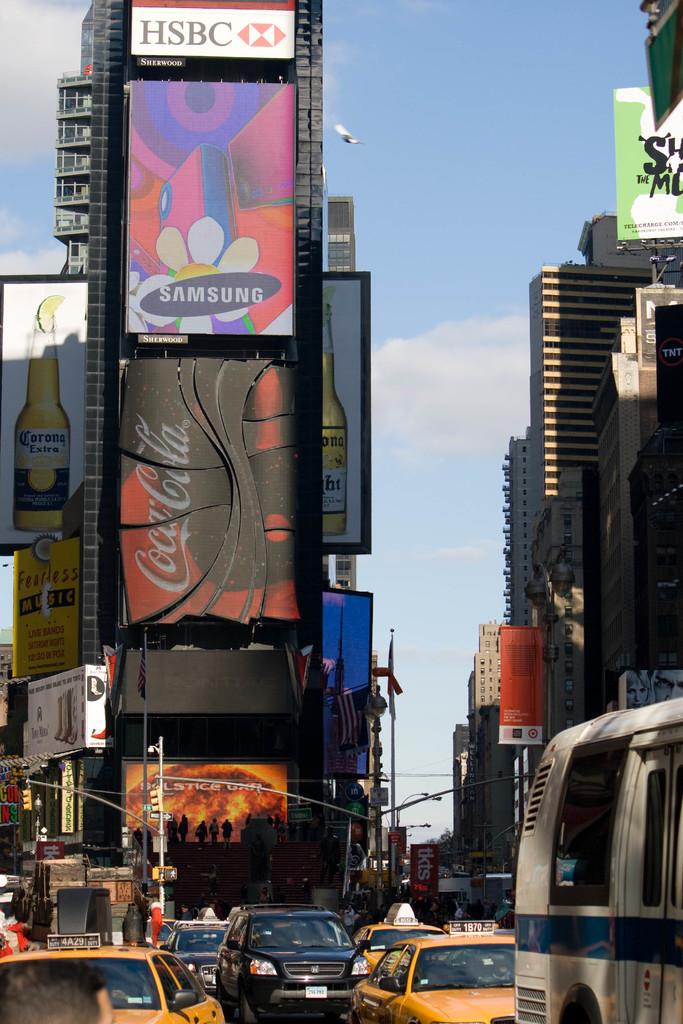What bank is on the top ad?
Your response must be concise. Hsbc. What cola brand is shown on the billboard?
Provide a short and direct response. Coca cola. 